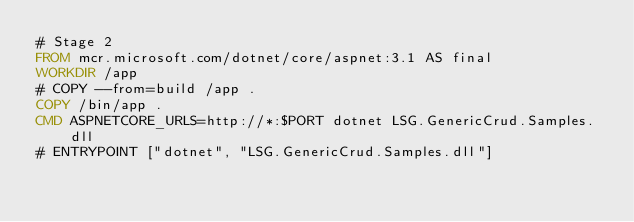Convert code to text. <code><loc_0><loc_0><loc_500><loc_500><_Dockerfile_># Stage 2
FROM mcr.microsoft.com/dotnet/core/aspnet:3.1 AS final
WORKDIR /app
# COPY --from=build /app .
COPY /bin/app .
CMD ASPNETCORE_URLS=http://*:$PORT dotnet LSG.GenericCrud.Samples.dll
# ENTRYPOINT ["dotnet", "LSG.GenericCrud.Samples.dll"]</code> 